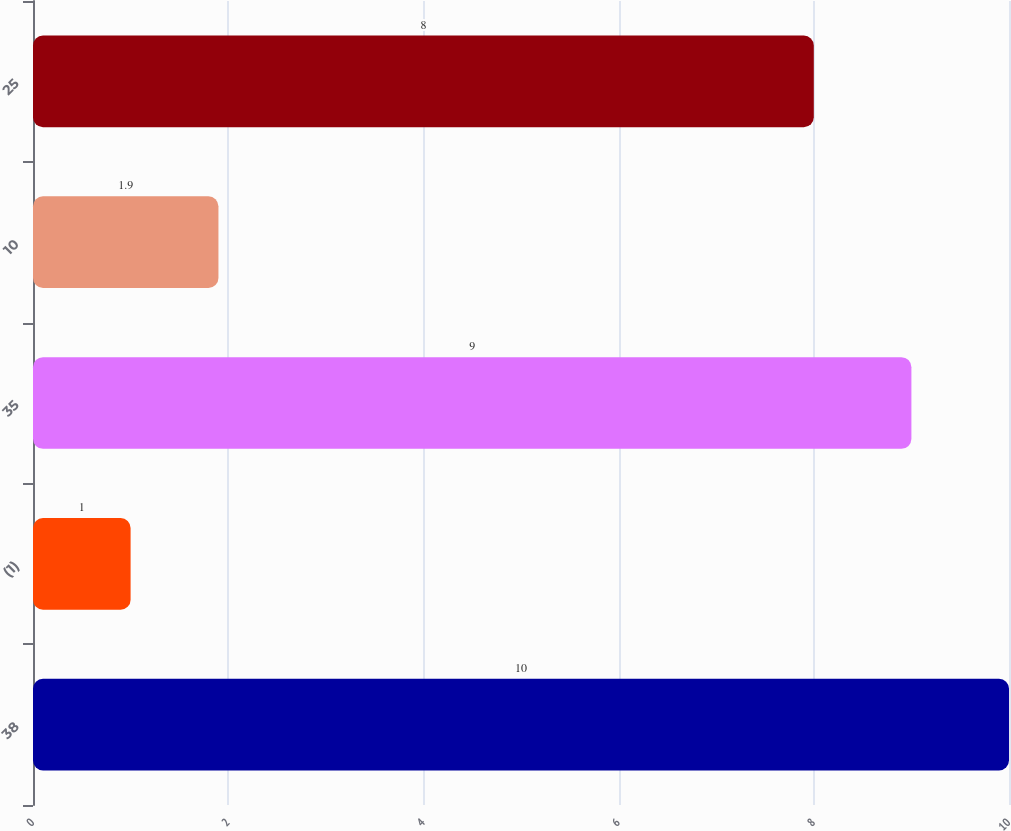<chart> <loc_0><loc_0><loc_500><loc_500><bar_chart><fcel>38<fcel>(1)<fcel>35<fcel>10<fcel>25<nl><fcel>10<fcel>1<fcel>9<fcel>1.9<fcel>8<nl></chart> 